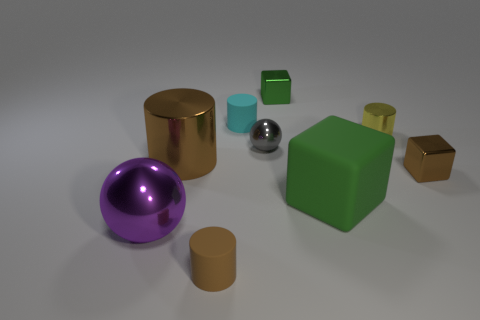Add 1 big purple spheres. How many objects exist? 10 Subtract all cyan cylinders. How many cylinders are left? 3 Subtract all tiny metal cylinders. How many cylinders are left? 3 Add 5 large things. How many large things exist? 8 Subtract 1 brown blocks. How many objects are left? 8 Subtract all spheres. How many objects are left? 7 Subtract 1 cylinders. How many cylinders are left? 3 Subtract all cyan balls. Subtract all purple blocks. How many balls are left? 2 Subtract all green cylinders. How many blue balls are left? 0 Subtract all large things. Subtract all gray shiny spheres. How many objects are left? 5 